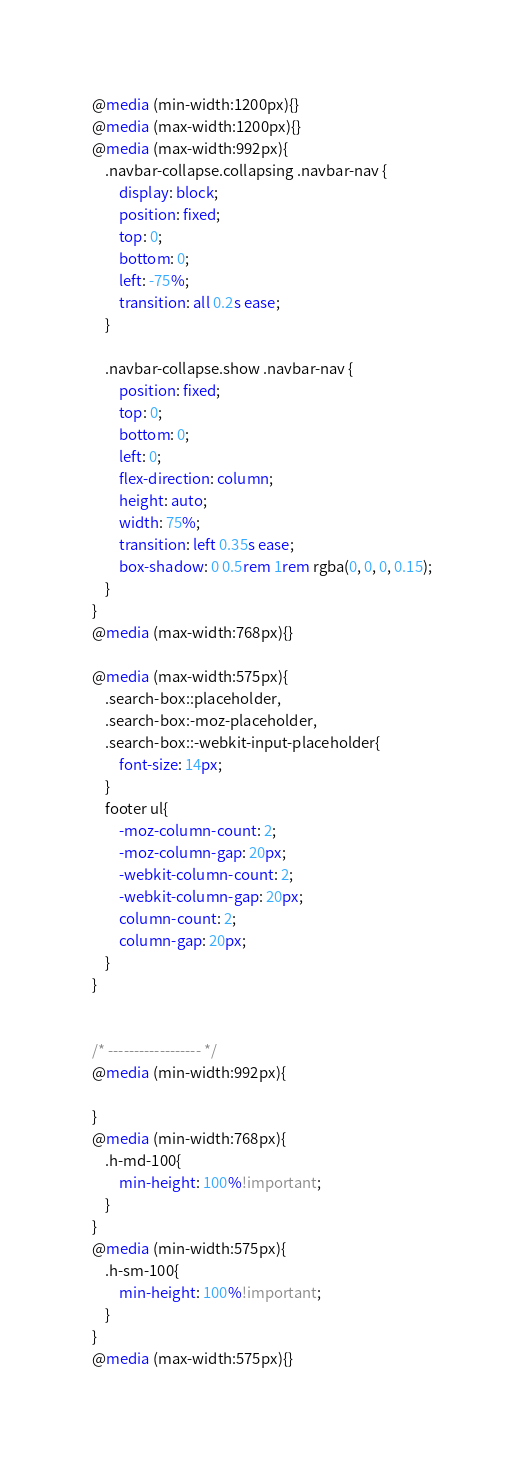Convert code to text. <code><loc_0><loc_0><loc_500><loc_500><_CSS_>@media (min-width:1200px){}
@media (max-width:1200px){}
@media (max-width:992px){
    .navbar-collapse.collapsing .navbar-nav {
        display: block;
        position: fixed;
        top: 0;
        bottom: 0;
        left: -75%;
        transition: all 0.2s ease;
    }

    .navbar-collapse.show .navbar-nav {
        position: fixed;
        top: 0;
        bottom: 0;
        left: 0;
        flex-direction: column;
        height: auto;
        width: 75%;
        transition: left 0.35s ease;
        box-shadow: 0 0.5rem 1rem rgba(0, 0, 0, 0.15);
    }
}
@media (max-width:768px){}

@media (max-width:575px){
    .search-box::placeholder,
    .search-box:-moz-placeholder,
    .search-box::-webkit-input-placeholder{
        font-size: 14px;
    }
    footer ul{
        -moz-column-count: 2;
        -moz-column-gap: 20px;
        -webkit-column-count: 2;
        -webkit-column-gap: 20px;
        column-count: 2;
        column-gap: 20px;
    }
}


/* ------------------ */
@media (min-width:992px){
    
}
@media (min-width:768px){
    .h-md-100{
        min-height: 100%!important;
    }
}
@media (min-width:575px){
    .h-sm-100{
        min-height: 100%!important;
    }
}
@media (max-width:575px){}


</code> 